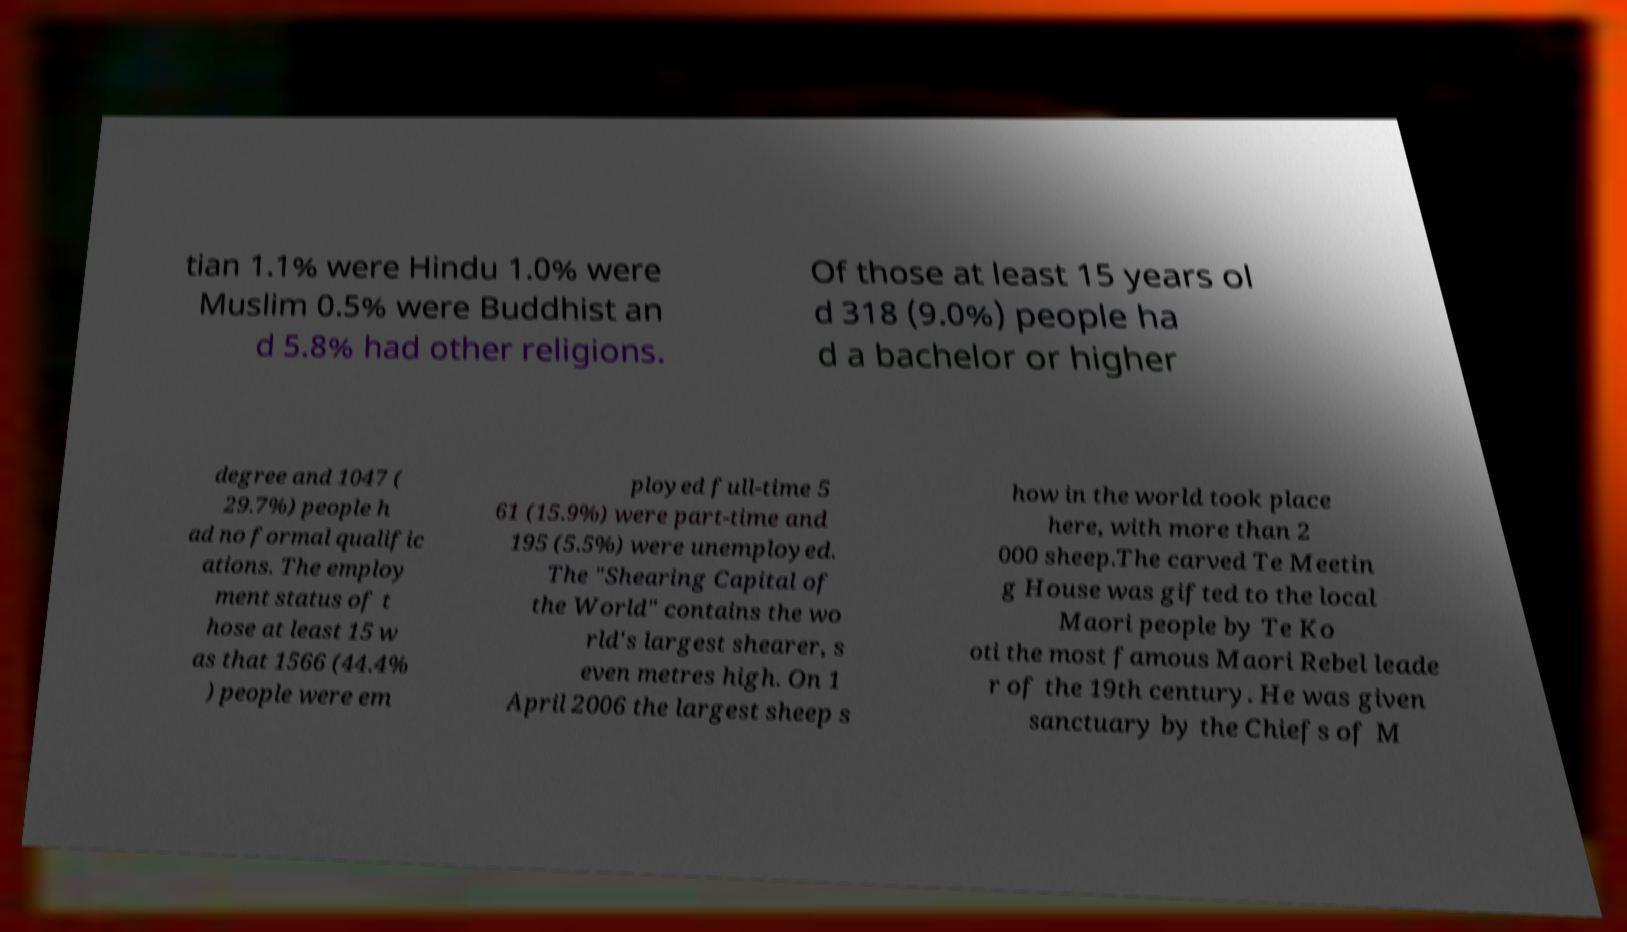I need the written content from this picture converted into text. Can you do that? tian 1.1% were Hindu 1.0% were Muslim 0.5% were Buddhist an d 5.8% had other religions. Of those at least 15 years ol d 318 (9.0%) people ha d a bachelor or higher degree and 1047 ( 29.7%) people h ad no formal qualific ations. The employ ment status of t hose at least 15 w as that 1566 (44.4% ) people were em ployed full-time 5 61 (15.9%) were part-time and 195 (5.5%) were unemployed. The "Shearing Capital of the World" contains the wo rld's largest shearer, s even metres high. On 1 April 2006 the largest sheep s how in the world took place here, with more than 2 000 sheep.The carved Te Meetin g House was gifted to the local Maori people by Te Ko oti the most famous Maori Rebel leade r of the 19th century. He was given sanctuary by the Chiefs of M 